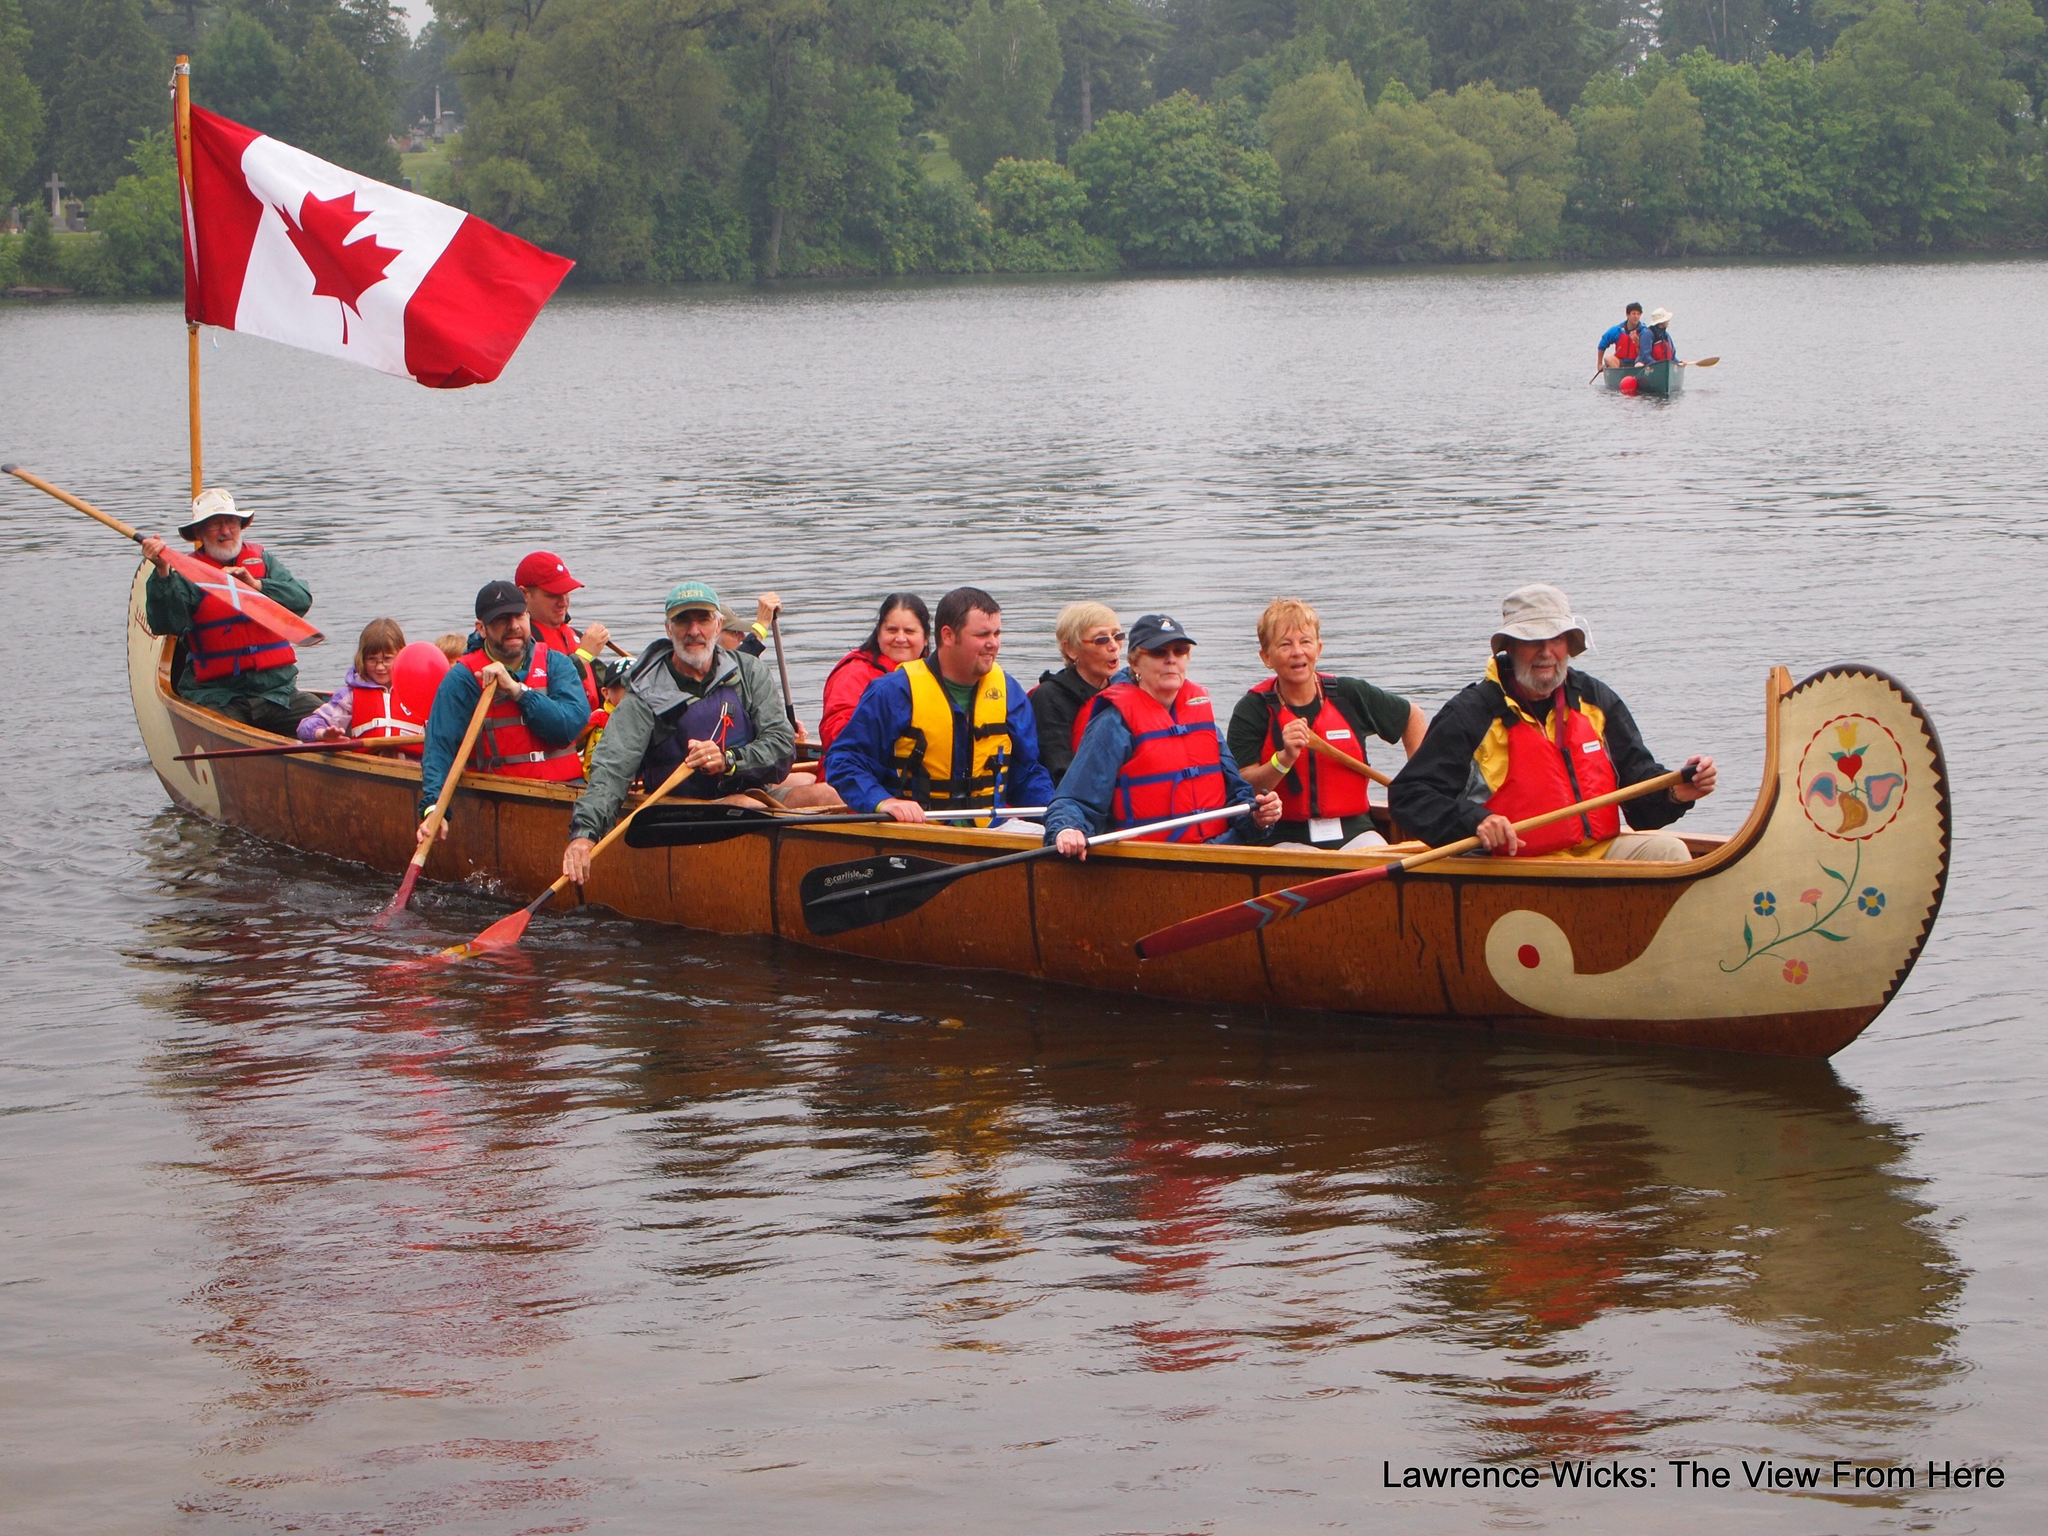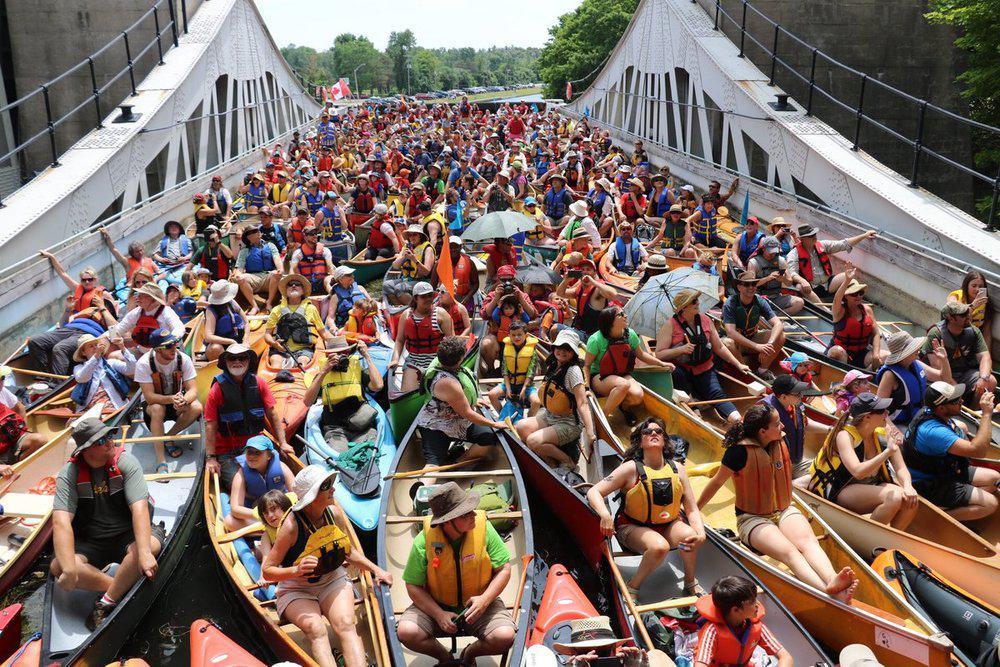The first image is the image on the left, the second image is the image on the right. For the images displayed, is the sentence "In at least one image, canoes are docked at the water edge with no people present." factually correct? Answer yes or no. No. 